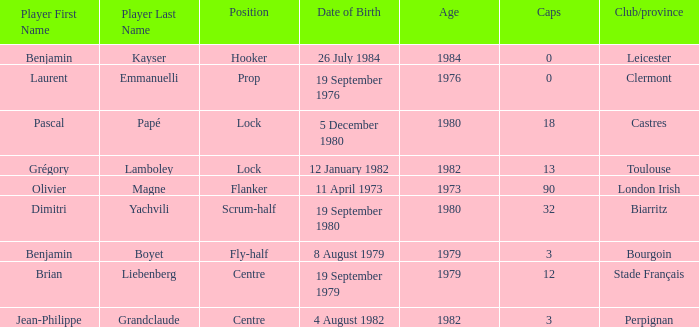Where is perpignan situated? Centre. 